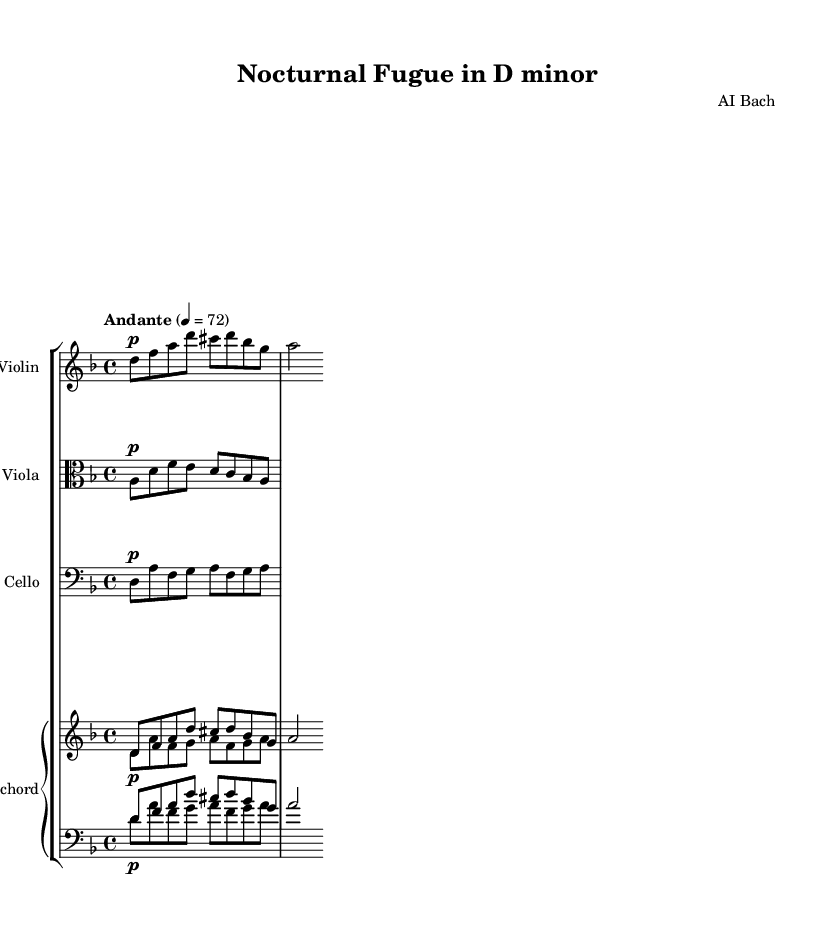What is the key signature of this music? The key signature for D minor, which has one flat (B flat), can be identified in the key signature section at the beginning of the piece. The presence of one flat corresponds to D minor.
Answer: D minor What is the time signature of this music? The time signature is indicated at the beginning of the piece, and it is shown as 4/4. This means there are 4 beats in each measure and a quarter note receives one beat.
Answer: 4/4 What is the tempo marking of this piece? The tempo marking is indicated above the staff and is written as "Andante" with a metronome marking of 72. "Andante" suggests a moderately slow tempo.
Answer: Andante 4 = 72 How many instruments are featured in this composition? The score includes four distinct instrumental parts: Violin, Viola, Cello, and Harpsichord. By counting each staff, one can determine the number of instruments present.
Answer: Four Which instrument plays the upper voice in the harpsichord part? The part labeled "upper" within the harpsichord section of the score indicates the specific instrument voice that plays higher notes. In this composition, the upper voice plays the same phrases as the violin.
Answer: Violin What dynamics are indicated for the cello part? The notation for the cello part shows a dynamic marking labeled "p," indicating a piano or soft playing style. This marking appears at the beginning of the cello line.
Answer: Piano Explain the significance of the term 'fugue' in this piece. A fugue is a compositional technique characterized by the interweaving of multiple voices and themes. In this piece, the title “Nocturnal Fugue” suggests that the music includes imitative counterpoint, which is typical of the Baroque style. Fugues often explore a theme introduced by one voice and developed by others.
Answer: It indicates interweaving voices 